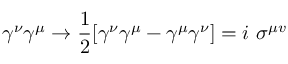<formula> <loc_0><loc_0><loc_500><loc_500>\gamma ^ { \nu } \gamma ^ { \mu } \to { \frac { 1 } { 2 } } [ \gamma ^ { \nu } \gamma ^ { \mu } - \gamma ^ { \mu } \gamma ^ { \nu } ] = i \sigma ^ { \mu v }</formula> 